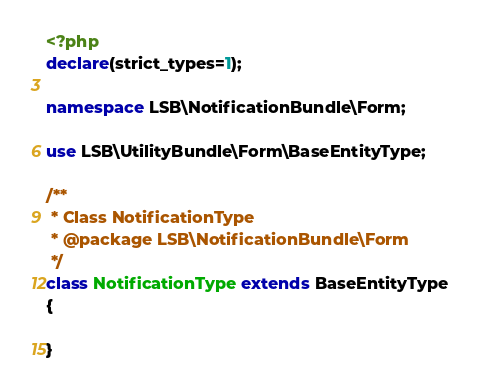Convert code to text. <code><loc_0><loc_0><loc_500><loc_500><_PHP_><?php
declare(strict_types=1);

namespace LSB\NotificationBundle\Form;

use LSB\UtilityBundle\Form\BaseEntityType;

/**
 * Class NotificationType
 * @package LSB\NotificationBundle\Form
 */
class NotificationType extends BaseEntityType
{

}
</code> 